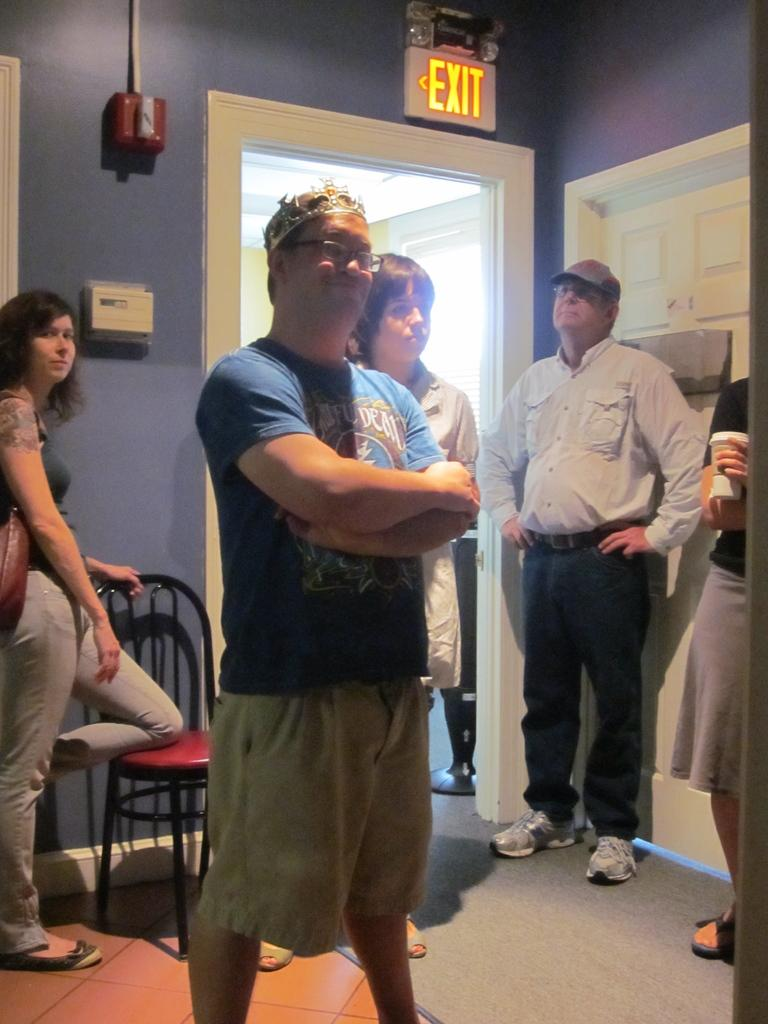How many people are in the image? There is a group of people standing in the image. What type of furniture is visible in the image? There is a chair in the image. What architectural feature can be seen in the image? There is a door in the image. What safety feature is attached to the wall in the image? There is an exit board attached to the wall in the image. What type of stem is growing out of the chair in the image? There is no stem growing out of the chair in the image. What government policy is being discussed by the group of people in the image? The image does not provide any information about a discussion or government policy. 